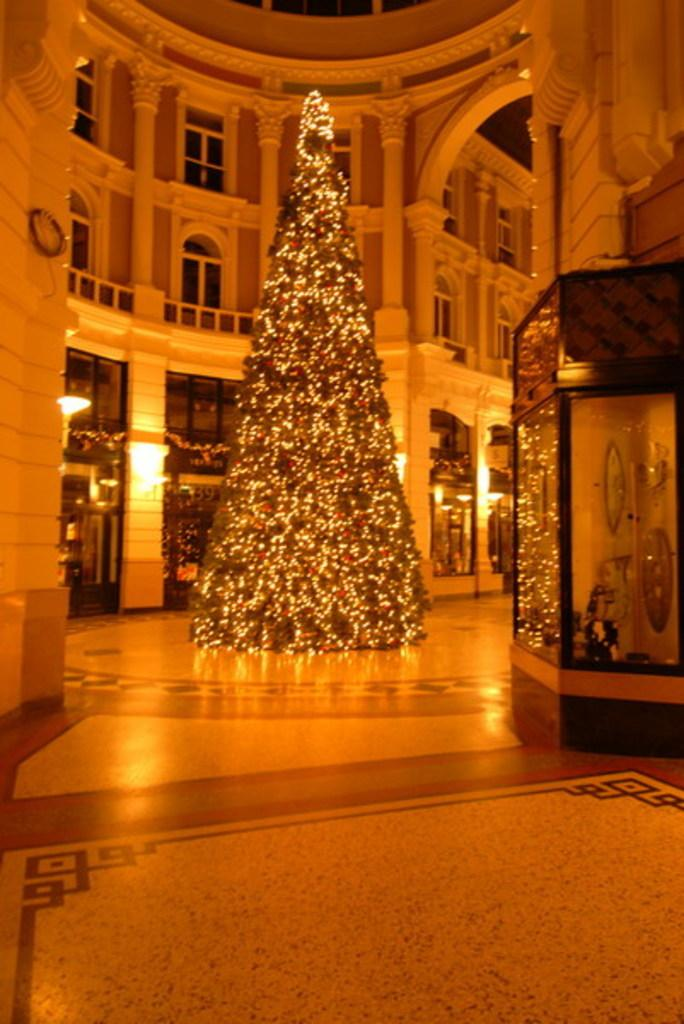What is the main subject of the image? There is a Christmas tree in the image. Where is the Christmas tree located? The Christmas tree is inside a building. How is the Christmas tree decorated? The Christmas tree is decorated with lights. What can be seen on the right side of the image? There is a display chamber on the right side of the image. Can you see a worm crawling on the Christmas tree in the image? No, there is no worm present on the Christmas tree in the image. 